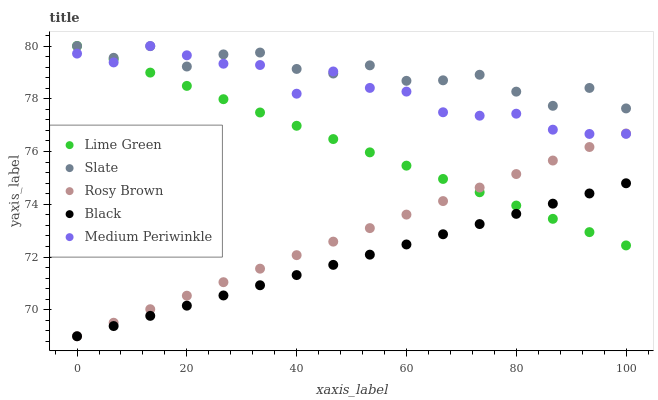Does Black have the minimum area under the curve?
Answer yes or no. Yes. Does Slate have the maximum area under the curve?
Answer yes or no. Yes. Does Rosy Brown have the minimum area under the curve?
Answer yes or no. No. Does Rosy Brown have the maximum area under the curve?
Answer yes or no. No. Is Lime Green the smoothest?
Answer yes or no. Yes. Is Slate the roughest?
Answer yes or no. Yes. Is Rosy Brown the smoothest?
Answer yes or no. No. Is Rosy Brown the roughest?
Answer yes or no. No. Does Black have the lowest value?
Answer yes or no. Yes. Does Slate have the lowest value?
Answer yes or no. No. Does Medium Periwinkle have the highest value?
Answer yes or no. Yes. Does Rosy Brown have the highest value?
Answer yes or no. No. Is Black less than Medium Periwinkle?
Answer yes or no. Yes. Is Medium Periwinkle greater than Black?
Answer yes or no. Yes. Does Rosy Brown intersect Lime Green?
Answer yes or no. Yes. Is Rosy Brown less than Lime Green?
Answer yes or no. No. Is Rosy Brown greater than Lime Green?
Answer yes or no. No. Does Black intersect Medium Periwinkle?
Answer yes or no. No. 